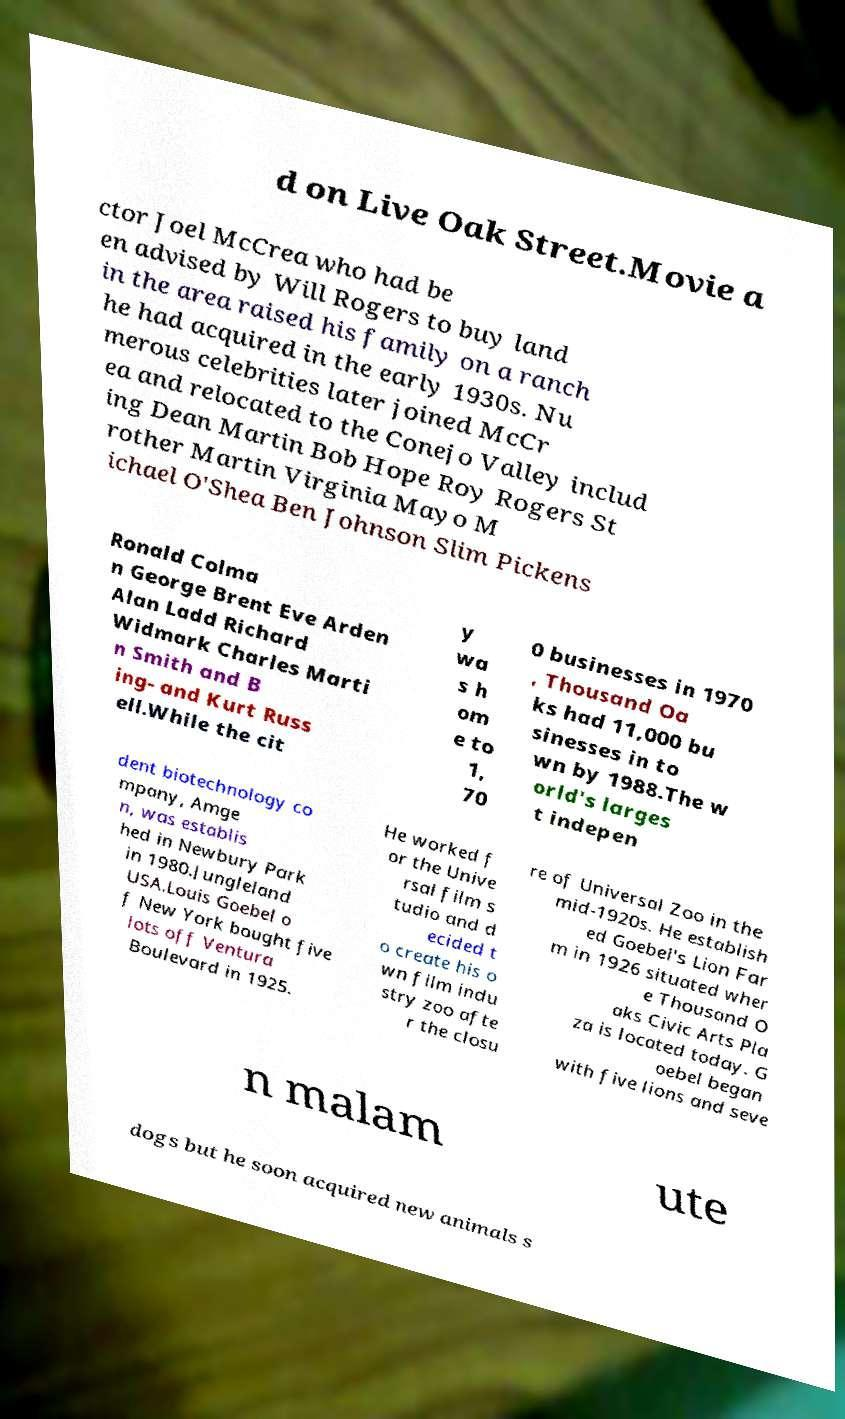What messages or text are displayed in this image? I need them in a readable, typed format. d on Live Oak Street.Movie a ctor Joel McCrea who had be en advised by Will Rogers to buy land in the area raised his family on a ranch he had acquired in the early 1930s. Nu merous celebrities later joined McCr ea and relocated to the Conejo Valley includ ing Dean Martin Bob Hope Roy Rogers St rother Martin Virginia Mayo M ichael O'Shea Ben Johnson Slim Pickens Ronald Colma n George Brent Eve Arden Alan Ladd Richard Widmark Charles Marti n Smith and B ing- and Kurt Russ ell.While the cit y wa s h om e to 1, 70 0 businesses in 1970 , Thousand Oa ks had 11,000 bu sinesses in to wn by 1988.The w orld's larges t indepen dent biotechnology co mpany, Amge n, was establis hed in Newbury Park in 1980.Jungleland USA.Louis Goebel o f New York bought five lots off Ventura Boulevard in 1925. He worked f or the Unive rsal film s tudio and d ecided t o create his o wn film indu stry zoo afte r the closu re of Universal Zoo in the mid-1920s. He establish ed Goebel's Lion Far m in 1926 situated wher e Thousand O aks Civic Arts Pla za is located today. G oebel began with five lions and seve n malam ute dogs but he soon acquired new animals s 